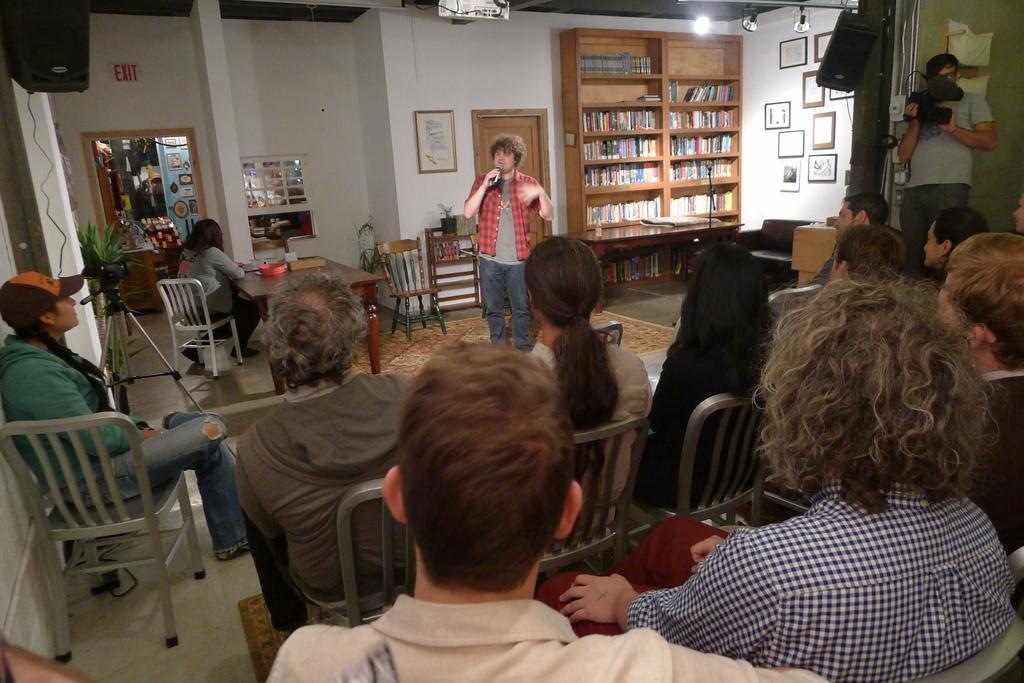Can you describe this image briefly? In this picture there are group of people, those who are sitting at the right side of the image and there is a person who is standing at the center of the image he is explaining something in the mic and there is a bookshelf at the right side of the image and there is a person who is standing at the right side of the image he is taking the video. 